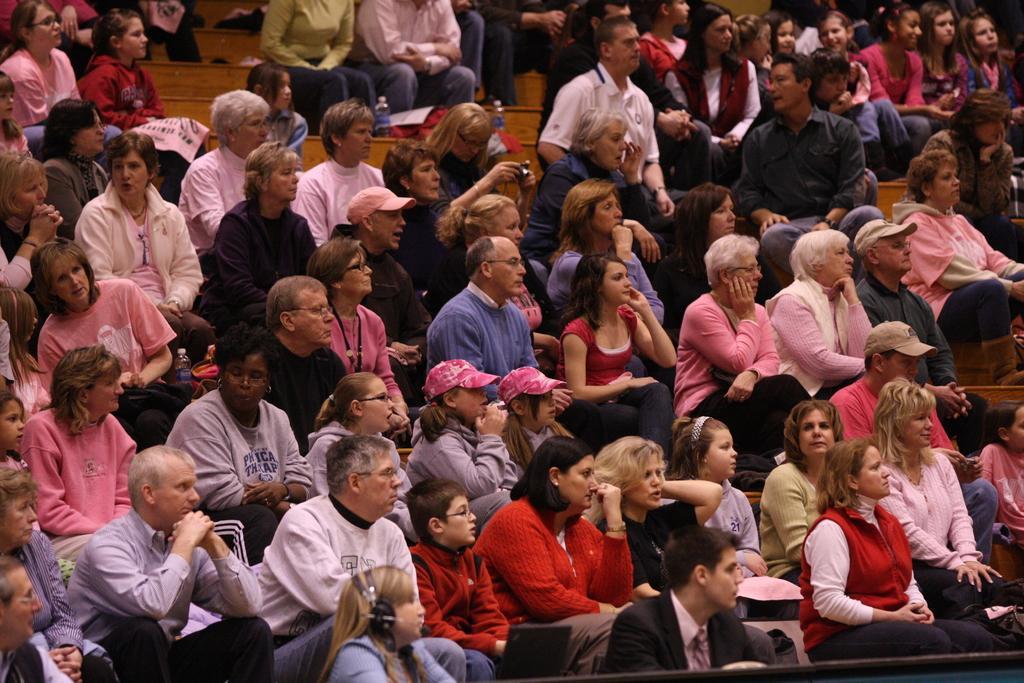Can you describe this image briefly? In this image we can see a few people, some of them are sitting on the seats, some people are wearing caps, there are posters with text on them, also we can bottles. 